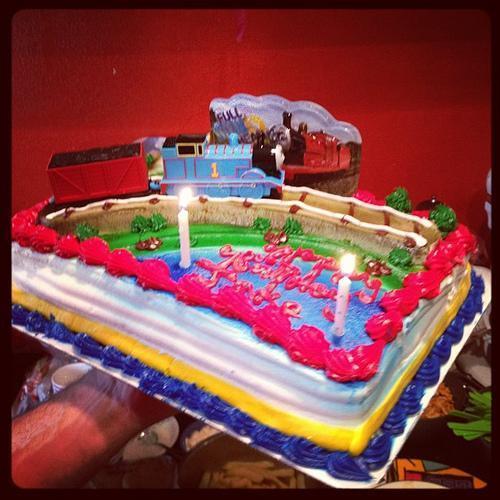How many trains are there?
Give a very brief answer. 2. How many candles are on the cake?
Give a very brief answer. 2. How many cakes are in the photo?
Give a very brief answer. 1. 